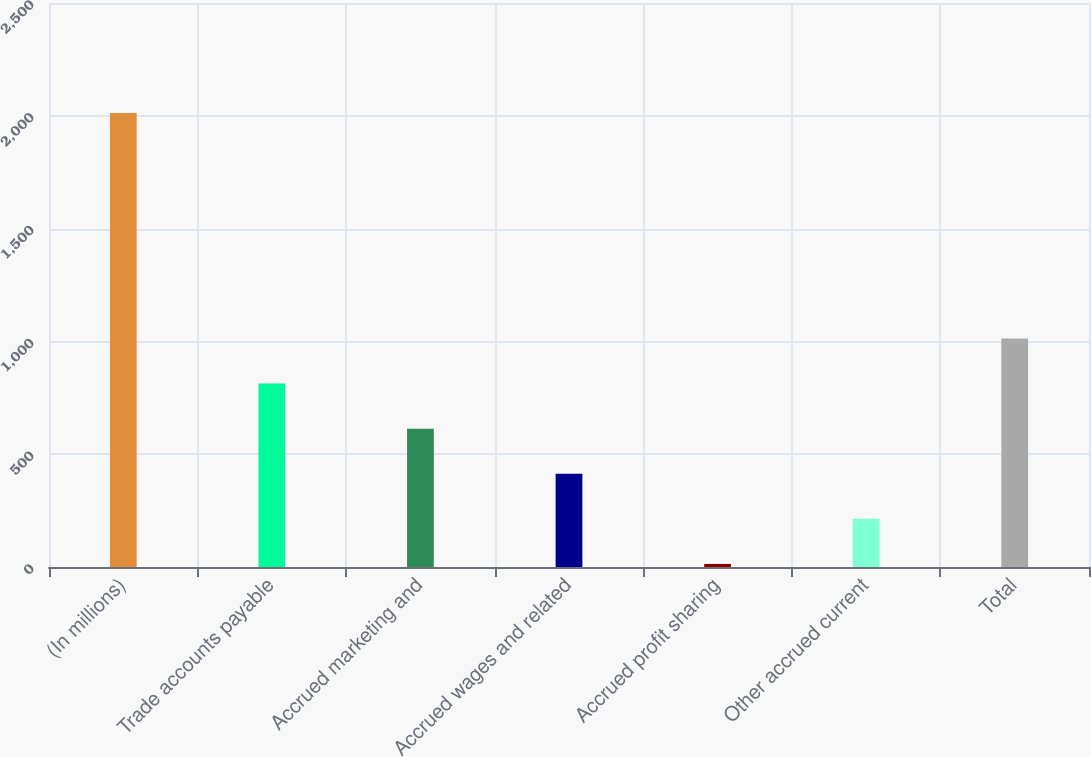Convert chart to OTSL. <chart><loc_0><loc_0><loc_500><loc_500><bar_chart><fcel>(In millions)<fcel>Trade accounts payable<fcel>Accrued marketing and<fcel>Accrued wages and related<fcel>Accrued profit sharing<fcel>Other accrued current<fcel>Total<nl><fcel>2012<fcel>812.96<fcel>613.12<fcel>413.28<fcel>13.6<fcel>213.44<fcel>1012.8<nl></chart> 